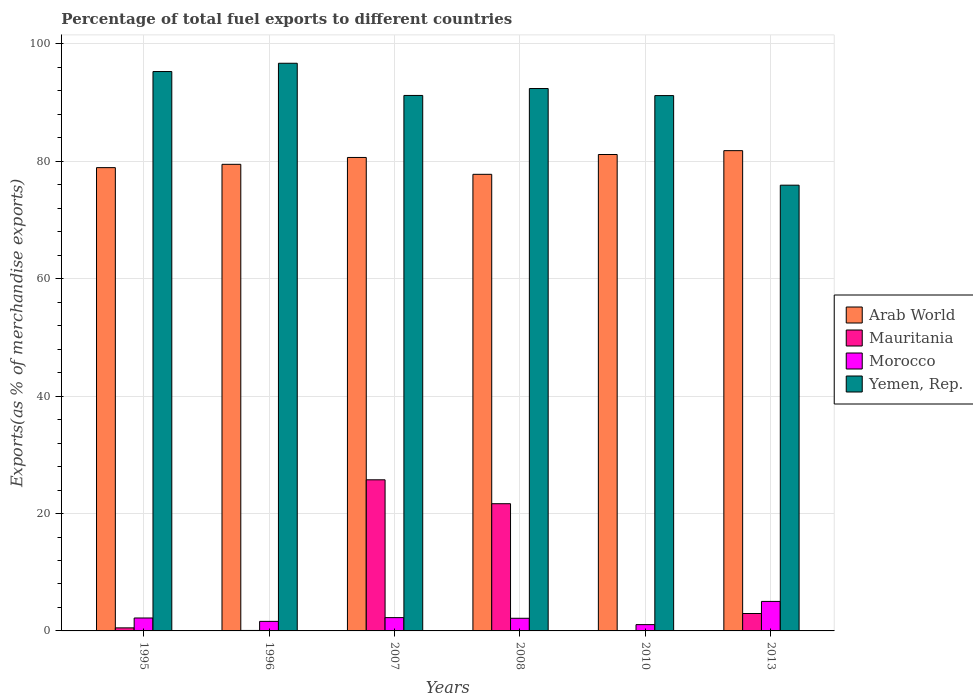How many different coloured bars are there?
Keep it short and to the point. 4. How many groups of bars are there?
Offer a very short reply. 6. Are the number of bars per tick equal to the number of legend labels?
Your answer should be compact. Yes. Are the number of bars on each tick of the X-axis equal?
Offer a terse response. Yes. How many bars are there on the 5th tick from the left?
Give a very brief answer. 4. In how many cases, is the number of bars for a given year not equal to the number of legend labels?
Your answer should be very brief. 0. What is the percentage of exports to different countries in Morocco in 2007?
Provide a succinct answer. 2.27. Across all years, what is the maximum percentage of exports to different countries in Yemen, Rep.?
Offer a very short reply. 96.71. Across all years, what is the minimum percentage of exports to different countries in Yemen, Rep.?
Provide a short and direct response. 75.94. What is the total percentage of exports to different countries in Mauritania in the graph?
Your answer should be very brief. 50.98. What is the difference between the percentage of exports to different countries in Mauritania in 2007 and that in 2013?
Your response must be concise. 22.78. What is the difference between the percentage of exports to different countries in Morocco in 2008 and the percentage of exports to different countries in Arab World in 2010?
Give a very brief answer. -79.01. What is the average percentage of exports to different countries in Mauritania per year?
Your answer should be very brief. 8.5. In the year 1995, what is the difference between the percentage of exports to different countries in Arab World and percentage of exports to different countries in Yemen, Rep.?
Provide a succinct answer. -16.37. What is the ratio of the percentage of exports to different countries in Arab World in 1995 to that in 2008?
Offer a terse response. 1.01. Is the difference between the percentage of exports to different countries in Arab World in 2007 and 2008 greater than the difference between the percentage of exports to different countries in Yemen, Rep. in 2007 and 2008?
Make the answer very short. Yes. What is the difference between the highest and the second highest percentage of exports to different countries in Mauritania?
Give a very brief answer. 4.07. What is the difference between the highest and the lowest percentage of exports to different countries in Yemen, Rep.?
Offer a terse response. 20.77. In how many years, is the percentage of exports to different countries in Mauritania greater than the average percentage of exports to different countries in Mauritania taken over all years?
Offer a very short reply. 2. What does the 1st bar from the left in 1996 represents?
Provide a succinct answer. Arab World. What does the 3rd bar from the right in 1996 represents?
Make the answer very short. Mauritania. Is it the case that in every year, the sum of the percentage of exports to different countries in Arab World and percentage of exports to different countries in Mauritania is greater than the percentage of exports to different countries in Morocco?
Keep it short and to the point. Yes. Are all the bars in the graph horizontal?
Make the answer very short. No. Are the values on the major ticks of Y-axis written in scientific E-notation?
Provide a succinct answer. No. How are the legend labels stacked?
Make the answer very short. Vertical. What is the title of the graph?
Make the answer very short. Percentage of total fuel exports to different countries. Does "Greece" appear as one of the legend labels in the graph?
Offer a very short reply. No. What is the label or title of the Y-axis?
Give a very brief answer. Exports(as % of merchandise exports). What is the Exports(as % of merchandise exports) of Arab World in 1995?
Offer a very short reply. 78.93. What is the Exports(as % of merchandise exports) in Mauritania in 1995?
Your answer should be very brief. 0.52. What is the Exports(as % of merchandise exports) of Morocco in 1995?
Make the answer very short. 2.2. What is the Exports(as % of merchandise exports) in Yemen, Rep. in 1995?
Make the answer very short. 95.3. What is the Exports(as % of merchandise exports) in Arab World in 1996?
Ensure brevity in your answer.  79.49. What is the Exports(as % of merchandise exports) of Mauritania in 1996?
Your answer should be very brief. 0.08. What is the Exports(as % of merchandise exports) in Morocco in 1996?
Your response must be concise. 1.63. What is the Exports(as % of merchandise exports) in Yemen, Rep. in 1996?
Your answer should be very brief. 96.71. What is the Exports(as % of merchandise exports) of Arab World in 2007?
Your answer should be very brief. 80.66. What is the Exports(as % of merchandise exports) in Mauritania in 2007?
Ensure brevity in your answer.  25.74. What is the Exports(as % of merchandise exports) of Morocco in 2007?
Provide a succinct answer. 2.27. What is the Exports(as % of merchandise exports) of Yemen, Rep. in 2007?
Your answer should be compact. 91.23. What is the Exports(as % of merchandise exports) of Arab World in 2008?
Provide a succinct answer. 77.79. What is the Exports(as % of merchandise exports) in Mauritania in 2008?
Provide a succinct answer. 21.67. What is the Exports(as % of merchandise exports) in Morocco in 2008?
Your response must be concise. 2.15. What is the Exports(as % of merchandise exports) of Yemen, Rep. in 2008?
Make the answer very short. 92.41. What is the Exports(as % of merchandise exports) in Arab World in 2010?
Give a very brief answer. 81.17. What is the Exports(as % of merchandise exports) of Mauritania in 2010?
Make the answer very short. 0. What is the Exports(as % of merchandise exports) of Morocco in 2010?
Your answer should be compact. 1.07. What is the Exports(as % of merchandise exports) of Yemen, Rep. in 2010?
Ensure brevity in your answer.  91.2. What is the Exports(as % of merchandise exports) in Arab World in 2013?
Your answer should be compact. 81.82. What is the Exports(as % of merchandise exports) of Mauritania in 2013?
Ensure brevity in your answer.  2.97. What is the Exports(as % of merchandise exports) in Morocco in 2013?
Provide a succinct answer. 5.03. What is the Exports(as % of merchandise exports) in Yemen, Rep. in 2013?
Give a very brief answer. 75.94. Across all years, what is the maximum Exports(as % of merchandise exports) of Arab World?
Your answer should be very brief. 81.82. Across all years, what is the maximum Exports(as % of merchandise exports) in Mauritania?
Make the answer very short. 25.74. Across all years, what is the maximum Exports(as % of merchandise exports) of Morocco?
Provide a short and direct response. 5.03. Across all years, what is the maximum Exports(as % of merchandise exports) in Yemen, Rep.?
Make the answer very short. 96.71. Across all years, what is the minimum Exports(as % of merchandise exports) in Arab World?
Your answer should be compact. 77.79. Across all years, what is the minimum Exports(as % of merchandise exports) in Mauritania?
Your answer should be compact. 0. Across all years, what is the minimum Exports(as % of merchandise exports) in Morocco?
Your answer should be compact. 1.07. Across all years, what is the minimum Exports(as % of merchandise exports) in Yemen, Rep.?
Your response must be concise. 75.94. What is the total Exports(as % of merchandise exports) in Arab World in the graph?
Keep it short and to the point. 479.87. What is the total Exports(as % of merchandise exports) of Mauritania in the graph?
Your answer should be compact. 50.98. What is the total Exports(as % of merchandise exports) of Morocco in the graph?
Make the answer very short. 14.35. What is the total Exports(as % of merchandise exports) in Yemen, Rep. in the graph?
Offer a very short reply. 542.79. What is the difference between the Exports(as % of merchandise exports) in Arab World in 1995 and that in 1996?
Provide a succinct answer. -0.56. What is the difference between the Exports(as % of merchandise exports) of Mauritania in 1995 and that in 1996?
Make the answer very short. 0.44. What is the difference between the Exports(as % of merchandise exports) of Morocco in 1995 and that in 1996?
Ensure brevity in your answer.  0.58. What is the difference between the Exports(as % of merchandise exports) of Yemen, Rep. in 1995 and that in 1996?
Keep it short and to the point. -1.41. What is the difference between the Exports(as % of merchandise exports) of Arab World in 1995 and that in 2007?
Keep it short and to the point. -1.73. What is the difference between the Exports(as % of merchandise exports) in Mauritania in 1995 and that in 2007?
Provide a succinct answer. -25.23. What is the difference between the Exports(as % of merchandise exports) in Morocco in 1995 and that in 2007?
Your answer should be compact. -0.07. What is the difference between the Exports(as % of merchandise exports) of Yemen, Rep. in 1995 and that in 2007?
Provide a succinct answer. 4.07. What is the difference between the Exports(as % of merchandise exports) in Arab World in 1995 and that in 2008?
Offer a very short reply. 1.14. What is the difference between the Exports(as % of merchandise exports) of Mauritania in 1995 and that in 2008?
Your response must be concise. -21.15. What is the difference between the Exports(as % of merchandise exports) in Morocco in 1995 and that in 2008?
Your response must be concise. 0.05. What is the difference between the Exports(as % of merchandise exports) of Yemen, Rep. in 1995 and that in 2008?
Make the answer very short. 2.89. What is the difference between the Exports(as % of merchandise exports) of Arab World in 1995 and that in 2010?
Keep it short and to the point. -2.24. What is the difference between the Exports(as % of merchandise exports) of Mauritania in 1995 and that in 2010?
Your answer should be very brief. 0.52. What is the difference between the Exports(as % of merchandise exports) in Morocco in 1995 and that in 2010?
Your answer should be compact. 1.13. What is the difference between the Exports(as % of merchandise exports) of Yemen, Rep. in 1995 and that in 2010?
Your answer should be compact. 4.1. What is the difference between the Exports(as % of merchandise exports) of Arab World in 1995 and that in 2013?
Ensure brevity in your answer.  -2.89. What is the difference between the Exports(as % of merchandise exports) of Mauritania in 1995 and that in 2013?
Offer a very short reply. -2.45. What is the difference between the Exports(as % of merchandise exports) in Morocco in 1995 and that in 2013?
Offer a terse response. -2.83. What is the difference between the Exports(as % of merchandise exports) in Yemen, Rep. in 1995 and that in 2013?
Keep it short and to the point. 19.36. What is the difference between the Exports(as % of merchandise exports) of Arab World in 1996 and that in 2007?
Keep it short and to the point. -1.17. What is the difference between the Exports(as % of merchandise exports) of Mauritania in 1996 and that in 2007?
Give a very brief answer. -25.66. What is the difference between the Exports(as % of merchandise exports) in Morocco in 1996 and that in 2007?
Make the answer very short. -0.64. What is the difference between the Exports(as % of merchandise exports) in Yemen, Rep. in 1996 and that in 2007?
Ensure brevity in your answer.  5.48. What is the difference between the Exports(as % of merchandise exports) of Arab World in 1996 and that in 2008?
Your answer should be very brief. 1.7. What is the difference between the Exports(as % of merchandise exports) of Mauritania in 1996 and that in 2008?
Offer a terse response. -21.59. What is the difference between the Exports(as % of merchandise exports) in Morocco in 1996 and that in 2008?
Your answer should be compact. -0.53. What is the difference between the Exports(as % of merchandise exports) in Yemen, Rep. in 1996 and that in 2008?
Offer a terse response. 4.3. What is the difference between the Exports(as % of merchandise exports) of Arab World in 1996 and that in 2010?
Make the answer very short. -1.67. What is the difference between the Exports(as % of merchandise exports) in Mauritania in 1996 and that in 2010?
Offer a terse response. 0.08. What is the difference between the Exports(as % of merchandise exports) in Morocco in 1996 and that in 2010?
Provide a succinct answer. 0.55. What is the difference between the Exports(as % of merchandise exports) of Yemen, Rep. in 1996 and that in 2010?
Provide a short and direct response. 5.51. What is the difference between the Exports(as % of merchandise exports) of Arab World in 1996 and that in 2013?
Provide a short and direct response. -2.33. What is the difference between the Exports(as % of merchandise exports) of Mauritania in 1996 and that in 2013?
Your response must be concise. -2.89. What is the difference between the Exports(as % of merchandise exports) of Morocco in 1996 and that in 2013?
Offer a terse response. -3.4. What is the difference between the Exports(as % of merchandise exports) of Yemen, Rep. in 1996 and that in 2013?
Offer a very short reply. 20.77. What is the difference between the Exports(as % of merchandise exports) of Arab World in 2007 and that in 2008?
Ensure brevity in your answer.  2.87. What is the difference between the Exports(as % of merchandise exports) in Mauritania in 2007 and that in 2008?
Give a very brief answer. 4.07. What is the difference between the Exports(as % of merchandise exports) in Morocco in 2007 and that in 2008?
Make the answer very short. 0.11. What is the difference between the Exports(as % of merchandise exports) of Yemen, Rep. in 2007 and that in 2008?
Your response must be concise. -1.18. What is the difference between the Exports(as % of merchandise exports) in Arab World in 2007 and that in 2010?
Ensure brevity in your answer.  -0.5. What is the difference between the Exports(as % of merchandise exports) in Mauritania in 2007 and that in 2010?
Your answer should be very brief. 25.74. What is the difference between the Exports(as % of merchandise exports) in Morocco in 2007 and that in 2010?
Offer a terse response. 1.19. What is the difference between the Exports(as % of merchandise exports) in Yemen, Rep. in 2007 and that in 2010?
Provide a short and direct response. 0.02. What is the difference between the Exports(as % of merchandise exports) in Arab World in 2007 and that in 2013?
Offer a very short reply. -1.16. What is the difference between the Exports(as % of merchandise exports) in Mauritania in 2007 and that in 2013?
Your response must be concise. 22.78. What is the difference between the Exports(as % of merchandise exports) in Morocco in 2007 and that in 2013?
Make the answer very short. -2.76. What is the difference between the Exports(as % of merchandise exports) of Yemen, Rep. in 2007 and that in 2013?
Your response must be concise. 15.29. What is the difference between the Exports(as % of merchandise exports) of Arab World in 2008 and that in 2010?
Give a very brief answer. -3.37. What is the difference between the Exports(as % of merchandise exports) of Mauritania in 2008 and that in 2010?
Your response must be concise. 21.67. What is the difference between the Exports(as % of merchandise exports) in Morocco in 2008 and that in 2010?
Make the answer very short. 1.08. What is the difference between the Exports(as % of merchandise exports) of Yemen, Rep. in 2008 and that in 2010?
Offer a terse response. 1.2. What is the difference between the Exports(as % of merchandise exports) of Arab World in 2008 and that in 2013?
Offer a very short reply. -4.03. What is the difference between the Exports(as % of merchandise exports) of Mauritania in 2008 and that in 2013?
Provide a succinct answer. 18.7. What is the difference between the Exports(as % of merchandise exports) in Morocco in 2008 and that in 2013?
Your response must be concise. -2.87. What is the difference between the Exports(as % of merchandise exports) of Yemen, Rep. in 2008 and that in 2013?
Your response must be concise. 16.47. What is the difference between the Exports(as % of merchandise exports) in Arab World in 2010 and that in 2013?
Offer a terse response. -0.66. What is the difference between the Exports(as % of merchandise exports) in Mauritania in 2010 and that in 2013?
Ensure brevity in your answer.  -2.97. What is the difference between the Exports(as % of merchandise exports) of Morocco in 2010 and that in 2013?
Your answer should be very brief. -3.96. What is the difference between the Exports(as % of merchandise exports) in Yemen, Rep. in 2010 and that in 2013?
Your answer should be very brief. 15.27. What is the difference between the Exports(as % of merchandise exports) of Arab World in 1995 and the Exports(as % of merchandise exports) of Mauritania in 1996?
Keep it short and to the point. 78.85. What is the difference between the Exports(as % of merchandise exports) in Arab World in 1995 and the Exports(as % of merchandise exports) in Morocco in 1996?
Your answer should be very brief. 77.3. What is the difference between the Exports(as % of merchandise exports) in Arab World in 1995 and the Exports(as % of merchandise exports) in Yemen, Rep. in 1996?
Offer a very short reply. -17.78. What is the difference between the Exports(as % of merchandise exports) of Mauritania in 1995 and the Exports(as % of merchandise exports) of Morocco in 1996?
Make the answer very short. -1.11. What is the difference between the Exports(as % of merchandise exports) in Mauritania in 1995 and the Exports(as % of merchandise exports) in Yemen, Rep. in 1996?
Ensure brevity in your answer.  -96.19. What is the difference between the Exports(as % of merchandise exports) of Morocco in 1995 and the Exports(as % of merchandise exports) of Yemen, Rep. in 1996?
Keep it short and to the point. -94.51. What is the difference between the Exports(as % of merchandise exports) in Arab World in 1995 and the Exports(as % of merchandise exports) in Mauritania in 2007?
Ensure brevity in your answer.  53.19. What is the difference between the Exports(as % of merchandise exports) of Arab World in 1995 and the Exports(as % of merchandise exports) of Morocco in 2007?
Your answer should be very brief. 76.66. What is the difference between the Exports(as % of merchandise exports) in Arab World in 1995 and the Exports(as % of merchandise exports) in Yemen, Rep. in 2007?
Offer a terse response. -12.3. What is the difference between the Exports(as % of merchandise exports) of Mauritania in 1995 and the Exports(as % of merchandise exports) of Morocco in 2007?
Your response must be concise. -1.75. What is the difference between the Exports(as % of merchandise exports) of Mauritania in 1995 and the Exports(as % of merchandise exports) of Yemen, Rep. in 2007?
Your answer should be compact. -90.71. What is the difference between the Exports(as % of merchandise exports) of Morocco in 1995 and the Exports(as % of merchandise exports) of Yemen, Rep. in 2007?
Offer a very short reply. -89.02. What is the difference between the Exports(as % of merchandise exports) of Arab World in 1995 and the Exports(as % of merchandise exports) of Mauritania in 2008?
Your answer should be very brief. 57.26. What is the difference between the Exports(as % of merchandise exports) in Arab World in 1995 and the Exports(as % of merchandise exports) in Morocco in 2008?
Make the answer very short. 76.78. What is the difference between the Exports(as % of merchandise exports) in Arab World in 1995 and the Exports(as % of merchandise exports) in Yemen, Rep. in 2008?
Make the answer very short. -13.48. What is the difference between the Exports(as % of merchandise exports) of Mauritania in 1995 and the Exports(as % of merchandise exports) of Morocco in 2008?
Offer a terse response. -1.63. What is the difference between the Exports(as % of merchandise exports) in Mauritania in 1995 and the Exports(as % of merchandise exports) in Yemen, Rep. in 2008?
Give a very brief answer. -91.89. What is the difference between the Exports(as % of merchandise exports) in Morocco in 1995 and the Exports(as % of merchandise exports) in Yemen, Rep. in 2008?
Give a very brief answer. -90.2. What is the difference between the Exports(as % of merchandise exports) in Arab World in 1995 and the Exports(as % of merchandise exports) in Mauritania in 2010?
Give a very brief answer. 78.93. What is the difference between the Exports(as % of merchandise exports) in Arab World in 1995 and the Exports(as % of merchandise exports) in Morocco in 2010?
Your answer should be very brief. 77.86. What is the difference between the Exports(as % of merchandise exports) in Arab World in 1995 and the Exports(as % of merchandise exports) in Yemen, Rep. in 2010?
Offer a very short reply. -12.27. What is the difference between the Exports(as % of merchandise exports) of Mauritania in 1995 and the Exports(as % of merchandise exports) of Morocco in 2010?
Your answer should be compact. -0.55. What is the difference between the Exports(as % of merchandise exports) of Mauritania in 1995 and the Exports(as % of merchandise exports) of Yemen, Rep. in 2010?
Your answer should be very brief. -90.69. What is the difference between the Exports(as % of merchandise exports) of Morocco in 1995 and the Exports(as % of merchandise exports) of Yemen, Rep. in 2010?
Give a very brief answer. -89. What is the difference between the Exports(as % of merchandise exports) in Arab World in 1995 and the Exports(as % of merchandise exports) in Mauritania in 2013?
Your answer should be very brief. 75.96. What is the difference between the Exports(as % of merchandise exports) in Arab World in 1995 and the Exports(as % of merchandise exports) in Morocco in 2013?
Your answer should be very brief. 73.9. What is the difference between the Exports(as % of merchandise exports) of Arab World in 1995 and the Exports(as % of merchandise exports) of Yemen, Rep. in 2013?
Ensure brevity in your answer.  2.99. What is the difference between the Exports(as % of merchandise exports) in Mauritania in 1995 and the Exports(as % of merchandise exports) in Morocco in 2013?
Offer a very short reply. -4.51. What is the difference between the Exports(as % of merchandise exports) of Mauritania in 1995 and the Exports(as % of merchandise exports) of Yemen, Rep. in 2013?
Offer a terse response. -75.42. What is the difference between the Exports(as % of merchandise exports) in Morocco in 1995 and the Exports(as % of merchandise exports) in Yemen, Rep. in 2013?
Ensure brevity in your answer.  -73.74. What is the difference between the Exports(as % of merchandise exports) in Arab World in 1996 and the Exports(as % of merchandise exports) in Mauritania in 2007?
Your response must be concise. 53.75. What is the difference between the Exports(as % of merchandise exports) in Arab World in 1996 and the Exports(as % of merchandise exports) in Morocco in 2007?
Offer a very short reply. 77.23. What is the difference between the Exports(as % of merchandise exports) in Arab World in 1996 and the Exports(as % of merchandise exports) in Yemen, Rep. in 2007?
Offer a terse response. -11.73. What is the difference between the Exports(as % of merchandise exports) of Mauritania in 1996 and the Exports(as % of merchandise exports) of Morocco in 2007?
Give a very brief answer. -2.19. What is the difference between the Exports(as % of merchandise exports) of Mauritania in 1996 and the Exports(as % of merchandise exports) of Yemen, Rep. in 2007?
Make the answer very short. -91.15. What is the difference between the Exports(as % of merchandise exports) of Morocco in 1996 and the Exports(as % of merchandise exports) of Yemen, Rep. in 2007?
Make the answer very short. -89.6. What is the difference between the Exports(as % of merchandise exports) of Arab World in 1996 and the Exports(as % of merchandise exports) of Mauritania in 2008?
Give a very brief answer. 57.82. What is the difference between the Exports(as % of merchandise exports) in Arab World in 1996 and the Exports(as % of merchandise exports) in Morocco in 2008?
Make the answer very short. 77.34. What is the difference between the Exports(as % of merchandise exports) of Arab World in 1996 and the Exports(as % of merchandise exports) of Yemen, Rep. in 2008?
Provide a succinct answer. -12.91. What is the difference between the Exports(as % of merchandise exports) in Mauritania in 1996 and the Exports(as % of merchandise exports) in Morocco in 2008?
Make the answer very short. -2.07. What is the difference between the Exports(as % of merchandise exports) of Mauritania in 1996 and the Exports(as % of merchandise exports) of Yemen, Rep. in 2008?
Make the answer very short. -92.33. What is the difference between the Exports(as % of merchandise exports) in Morocco in 1996 and the Exports(as % of merchandise exports) in Yemen, Rep. in 2008?
Offer a terse response. -90.78. What is the difference between the Exports(as % of merchandise exports) in Arab World in 1996 and the Exports(as % of merchandise exports) in Mauritania in 2010?
Give a very brief answer. 79.49. What is the difference between the Exports(as % of merchandise exports) in Arab World in 1996 and the Exports(as % of merchandise exports) in Morocco in 2010?
Offer a very short reply. 78.42. What is the difference between the Exports(as % of merchandise exports) of Arab World in 1996 and the Exports(as % of merchandise exports) of Yemen, Rep. in 2010?
Ensure brevity in your answer.  -11.71. What is the difference between the Exports(as % of merchandise exports) of Mauritania in 1996 and the Exports(as % of merchandise exports) of Morocco in 2010?
Offer a very short reply. -0.99. What is the difference between the Exports(as % of merchandise exports) in Mauritania in 1996 and the Exports(as % of merchandise exports) in Yemen, Rep. in 2010?
Ensure brevity in your answer.  -91.13. What is the difference between the Exports(as % of merchandise exports) of Morocco in 1996 and the Exports(as % of merchandise exports) of Yemen, Rep. in 2010?
Make the answer very short. -89.58. What is the difference between the Exports(as % of merchandise exports) in Arab World in 1996 and the Exports(as % of merchandise exports) in Mauritania in 2013?
Give a very brief answer. 76.53. What is the difference between the Exports(as % of merchandise exports) of Arab World in 1996 and the Exports(as % of merchandise exports) of Morocco in 2013?
Make the answer very short. 74.47. What is the difference between the Exports(as % of merchandise exports) in Arab World in 1996 and the Exports(as % of merchandise exports) in Yemen, Rep. in 2013?
Your answer should be compact. 3.56. What is the difference between the Exports(as % of merchandise exports) of Mauritania in 1996 and the Exports(as % of merchandise exports) of Morocco in 2013?
Your response must be concise. -4.95. What is the difference between the Exports(as % of merchandise exports) in Mauritania in 1996 and the Exports(as % of merchandise exports) in Yemen, Rep. in 2013?
Ensure brevity in your answer.  -75.86. What is the difference between the Exports(as % of merchandise exports) in Morocco in 1996 and the Exports(as % of merchandise exports) in Yemen, Rep. in 2013?
Offer a terse response. -74.31. What is the difference between the Exports(as % of merchandise exports) of Arab World in 2007 and the Exports(as % of merchandise exports) of Mauritania in 2008?
Give a very brief answer. 58.99. What is the difference between the Exports(as % of merchandise exports) in Arab World in 2007 and the Exports(as % of merchandise exports) in Morocco in 2008?
Offer a very short reply. 78.51. What is the difference between the Exports(as % of merchandise exports) in Arab World in 2007 and the Exports(as % of merchandise exports) in Yemen, Rep. in 2008?
Ensure brevity in your answer.  -11.74. What is the difference between the Exports(as % of merchandise exports) in Mauritania in 2007 and the Exports(as % of merchandise exports) in Morocco in 2008?
Your response must be concise. 23.59. What is the difference between the Exports(as % of merchandise exports) of Mauritania in 2007 and the Exports(as % of merchandise exports) of Yemen, Rep. in 2008?
Offer a very short reply. -66.66. What is the difference between the Exports(as % of merchandise exports) in Morocco in 2007 and the Exports(as % of merchandise exports) in Yemen, Rep. in 2008?
Your response must be concise. -90.14. What is the difference between the Exports(as % of merchandise exports) in Arab World in 2007 and the Exports(as % of merchandise exports) in Mauritania in 2010?
Provide a short and direct response. 80.66. What is the difference between the Exports(as % of merchandise exports) in Arab World in 2007 and the Exports(as % of merchandise exports) in Morocco in 2010?
Your response must be concise. 79.59. What is the difference between the Exports(as % of merchandise exports) in Arab World in 2007 and the Exports(as % of merchandise exports) in Yemen, Rep. in 2010?
Your answer should be very brief. -10.54. What is the difference between the Exports(as % of merchandise exports) in Mauritania in 2007 and the Exports(as % of merchandise exports) in Morocco in 2010?
Keep it short and to the point. 24.67. What is the difference between the Exports(as % of merchandise exports) of Mauritania in 2007 and the Exports(as % of merchandise exports) of Yemen, Rep. in 2010?
Provide a short and direct response. -65.46. What is the difference between the Exports(as % of merchandise exports) of Morocco in 2007 and the Exports(as % of merchandise exports) of Yemen, Rep. in 2010?
Keep it short and to the point. -88.94. What is the difference between the Exports(as % of merchandise exports) in Arab World in 2007 and the Exports(as % of merchandise exports) in Mauritania in 2013?
Ensure brevity in your answer.  77.7. What is the difference between the Exports(as % of merchandise exports) in Arab World in 2007 and the Exports(as % of merchandise exports) in Morocco in 2013?
Offer a very short reply. 75.64. What is the difference between the Exports(as % of merchandise exports) of Arab World in 2007 and the Exports(as % of merchandise exports) of Yemen, Rep. in 2013?
Your answer should be compact. 4.72. What is the difference between the Exports(as % of merchandise exports) in Mauritania in 2007 and the Exports(as % of merchandise exports) in Morocco in 2013?
Offer a terse response. 20.72. What is the difference between the Exports(as % of merchandise exports) in Mauritania in 2007 and the Exports(as % of merchandise exports) in Yemen, Rep. in 2013?
Keep it short and to the point. -50.19. What is the difference between the Exports(as % of merchandise exports) in Morocco in 2007 and the Exports(as % of merchandise exports) in Yemen, Rep. in 2013?
Your answer should be compact. -73.67. What is the difference between the Exports(as % of merchandise exports) in Arab World in 2008 and the Exports(as % of merchandise exports) in Mauritania in 2010?
Ensure brevity in your answer.  77.79. What is the difference between the Exports(as % of merchandise exports) of Arab World in 2008 and the Exports(as % of merchandise exports) of Morocco in 2010?
Provide a succinct answer. 76.72. What is the difference between the Exports(as % of merchandise exports) of Arab World in 2008 and the Exports(as % of merchandise exports) of Yemen, Rep. in 2010?
Make the answer very short. -13.41. What is the difference between the Exports(as % of merchandise exports) in Mauritania in 2008 and the Exports(as % of merchandise exports) in Morocco in 2010?
Give a very brief answer. 20.6. What is the difference between the Exports(as % of merchandise exports) in Mauritania in 2008 and the Exports(as % of merchandise exports) in Yemen, Rep. in 2010?
Offer a terse response. -69.53. What is the difference between the Exports(as % of merchandise exports) in Morocco in 2008 and the Exports(as % of merchandise exports) in Yemen, Rep. in 2010?
Your answer should be compact. -89.05. What is the difference between the Exports(as % of merchandise exports) in Arab World in 2008 and the Exports(as % of merchandise exports) in Mauritania in 2013?
Provide a short and direct response. 74.82. What is the difference between the Exports(as % of merchandise exports) of Arab World in 2008 and the Exports(as % of merchandise exports) of Morocco in 2013?
Provide a short and direct response. 72.76. What is the difference between the Exports(as % of merchandise exports) of Arab World in 2008 and the Exports(as % of merchandise exports) of Yemen, Rep. in 2013?
Offer a terse response. 1.85. What is the difference between the Exports(as % of merchandise exports) in Mauritania in 2008 and the Exports(as % of merchandise exports) in Morocco in 2013?
Your answer should be very brief. 16.64. What is the difference between the Exports(as % of merchandise exports) in Mauritania in 2008 and the Exports(as % of merchandise exports) in Yemen, Rep. in 2013?
Your answer should be compact. -54.27. What is the difference between the Exports(as % of merchandise exports) in Morocco in 2008 and the Exports(as % of merchandise exports) in Yemen, Rep. in 2013?
Keep it short and to the point. -73.78. What is the difference between the Exports(as % of merchandise exports) of Arab World in 2010 and the Exports(as % of merchandise exports) of Mauritania in 2013?
Provide a short and direct response. 78.2. What is the difference between the Exports(as % of merchandise exports) in Arab World in 2010 and the Exports(as % of merchandise exports) in Morocco in 2013?
Your answer should be compact. 76.14. What is the difference between the Exports(as % of merchandise exports) of Arab World in 2010 and the Exports(as % of merchandise exports) of Yemen, Rep. in 2013?
Your answer should be compact. 5.23. What is the difference between the Exports(as % of merchandise exports) in Mauritania in 2010 and the Exports(as % of merchandise exports) in Morocco in 2013?
Provide a short and direct response. -5.03. What is the difference between the Exports(as % of merchandise exports) in Mauritania in 2010 and the Exports(as % of merchandise exports) in Yemen, Rep. in 2013?
Your response must be concise. -75.94. What is the difference between the Exports(as % of merchandise exports) of Morocco in 2010 and the Exports(as % of merchandise exports) of Yemen, Rep. in 2013?
Your answer should be compact. -74.87. What is the average Exports(as % of merchandise exports) in Arab World per year?
Give a very brief answer. 79.98. What is the average Exports(as % of merchandise exports) of Mauritania per year?
Ensure brevity in your answer.  8.5. What is the average Exports(as % of merchandise exports) of Morocco per year?
Provide a succinct answer. 2.39. What is the average Exports(as % of merchandise exports) of Yemen, Rep. per year?
Offer a very short reply. 90.47. In the year 1995, what is the difference between the Exports(as % of merchandise exports) in Arab World and Exports(as % of merchandise exports) in Mauritania?
Provide a short and direct response. 78.41. In the year 1995, what is the difference between the Exports(as % of merchandise exports) in Arab World and Exports(as % of merchandise exports) in Morocco?
Make the answer very short. 76.73. In the year 1995, what is the difference between the Exports(as % of merchandise exports) in Arab World and Exports(as % of merchandise exports) in Yemen, Rep.?
Provide a succinct answer. -16.37. In the year 1995, what is the difference between the Exports(as % of merchandise exports) of Mauritania and Exports(as % of merchandise exports) of Morocco?
Provide a short and direct response. -1.68. In the year 1995, what is the difference between the Exports(as % of merchandise exports) of Mauritania and Exports(as % of merchandise exports) of Yemen, Rep.?
Offer a terse response. -94.78. In the year 1995, what is the difference between the Exports(as % of merchandise exports) in Morocco and Exports(as % of merchandise exports) in Yemen, Rep.?
Offer a terse response. -93.1. In the year 1996, what is the difference between the Exports(as % of merchandise exports) of Arab World and Exports(as % of merchandise exports) of Mauritania?
Ensure brevity in your answer.  79.42. In the year 1996, what is the difference between the Exports(as % of merchandise exports) in Arab World and Exports(as % of merchandise exports) in Morocco?
Offer a very short reply. 77.87. In the year 1996, what is the difference between the Exports(as % of merchandise exports) in Arab World and Exports(as % of merchandise exports) in Yemen, Rep.?
Your answer should be very brief. -17.22. In the year 1996, what is the difference between the Exports(as % of merchandise exports) in Mauritania and Exports(as % of merchandise exports) in Morocco?
Provide a succinct answer. -1.55. In the year 1996, what is the difference between the Exports(as % of merchandise exports) in Mauritania and Exports(as % of merchandise exports) in Yemen, Rep.?
Provide a short and direct response. -96.63. In the year 1996, what is the difference between the Exports(as % of merchandise exports) in Morocco and Exports(as % of merchandise exports) in Yemen, Rep.?
Offer a very short reply. -95.08. In the year 2007, what is the difference between the Exports(as % of merchandise exports) of Arab World and Exports(as % of merchandise exports) of Mauritania?
Your answer should be very brief. 54.92. In the year 2007, what is the difference between the Exports(as % of merchandise exports) of Arab World and Exports(as % of merchandise exports) of Morocco?
Your answer should be very brief. 78.4. In the year 2007, what is the difference between the Exports(as % of merchandise exports) of Arab World and Exports(as % of merchandise exports) of Yemen, Rep.?
Provide a short and direct response. -10.56. In the year 2007, what is the difference between the Exports(as % of merchandise exports) in Mauritania and Exports(as % of merchandise exports) in Morocco?
Your response must be concise. 23.48. In the year 2007, what is the difference between the Exports(as % of merchandise exports) in Mauritania and Exports(as % of merchandise exports) in Yemen, Rep.?
Give a very brief answer. -65.48. In the year 2007, what is the difference between the Exports(as % of merchandise exports) in Morocco and Exports(as % of merchandise exports) in Yemen, Rep.?
Keep it short and to the point. -88.96. In the year 2008, what is the difference between the Exports(as % of merchandise exports) in Arab World and Exports(as % of merchandise exports) in Mauritania?
Your answer should be compact. 56.12. In the year 2008, what is the difference between the Exports(as % of merchandise exports) in Arab World and Exports(as % of merchandise exports) in Morocco?
Offer a very short reply. 75.64. In the year 2008, what is the difference between the Exports(as % of merchandise exports) in Arab World and Exports(as % of merchandise exports) in Yemen, Rep.?
Offer a terse response. -14.62. In the year 2008, what is the difference between the Exports(as % of merchandise exports) in Mauritania and Exports(as % of merchandise exports) in Morocco?
Provide a short and direct response. 19.52. In the year 2008, what is the difference between the Exports(as % of merchandise exports) in Mauritania and Exports(as % of merchandise exports) in Yemen, Rep.?
Your response must be concise. -70.74. In the year 2008, what is the difference between the Exports(as % of merchandise exports) in Morocco and Exports(as % of merchandise exports) in Yemen, Rep.?
Your response must be concise. -90.25. In the year 2010, what is the difference between the Exports(as % of merchandise exports) of Arab World and Exports(as % of merchandise exports) of Mauritania?
Provide a succinct answer. 81.16. In the year 2010, what is the difference between the Exports(as % of merchandise exports) of Arab World and Exports(as % of merchandise exports) of Morocco?
Make the answer very short. 80.09. In the year 2010, what is the difference between the Exports(as % of merchandise exports) in Arab World and Exports(as % of merchandise exports) in Yemen, Rep.?
Provide a succinct answer. -10.04. In the year 2010, what is the difference between the Exports(as % of merchandise exports) of Mauritania and Exports(as % of merchandise exports) of Morocco?
Offer a terse response. -1.07. In the year 2010, what is the difference between the Exports(as % of merchandise exports) in Mauritania and Exports(as % of merchandise exports) in Yemen, Rep.?
Keep it short and to the point. -91.2. In the year 2010, what is the difference between the Exports(as % of merchandise exports) of Morocco and Exports(as % of merchandise exports) of Yemen, Rep.?
Make the answer very short. -90.13. In the year 2013, what is the difference between the Exports(as % of merchandise exports) of Arab World and Exports(as % of merchandise exports) of Mauritania?
Ensure brevity in your answer.  78.86. In the year 2013, what is the difference between the Exports(as % of merchandise exports) of Arab World and Exports(as % of merchandise exports) of Morocco?
Provide a succinct answer. 76.8. In the year 2013, what is the difference between the Exports(as % of merchandise exports) of Arab World and Exports(as % of merchandise exports) of Yemen, Rep.?
Make the answer very short. 5.88. In the year 2013, what is the difference between the Exports(as % of merchandise exports) in Mauritania and Exports(as % of merchandise exports) in Morocco?
Offer a terse response. -2.06. In the year 2013, what is the difference between the Exports(as % of merchandise exports) of Mauritania and Exports(as % of merchandise exports) of Yemen, Rep.?
Your answer should be compact. -72.97. In the year 2013, what is the difference between the Exports(as % of merchandise exports) in Morocco and Exports(as % of merchandise exports) in Yemen, Rep.?
Your response must be concise. -70.91. What is the ratio of the Exports(as % of merchandise exports) of Arab World in 1995 to that in 1996?
Make the answer very short. 0.99. What is the ratio of the Exports(as % of merchandise exports) of Mauritania in 1995 to that in 1996?
Ensure brevity in your answer.  6.51. What is the ratio of the Exports(as % of merchandise exports) in Morocco in 1995 to that in 1996?
Offer a terse response. 1.35. What is the ratio of the Exports(as % of merchandise exports) of Yemen, Rep. in 1995 to that in 1996?
Keep it short and to the point. 0.99. What is the ratio of the Exports(as % of merchandise exports) of Arab World in 1995 to that in 2007?
Offer a terse response. 0.98. What is the ratio of the Exports(as % of merchandise exports) of Mauritania in 1995 to that in 2007?
Ensure brevity in your answer.  0.02. What is the ratio of the Exports(as % of merchandise exports) in Morocco in 1995 to that in 2007?
Keep it short and to the point. 0.97. What is the ratio of the Exports(as % of merchandise exports) in Yemen, Rep. in 1995 to that in 2007?
Your answer should be compact. 1.04. What is the ratio of the Exports(as % of merchandise exports) in Arab World in 1995 to that in 2008?
Provide a short and direct response. 1.01. What is the ratio of the Exports(as % of merchandise exports) in Mauritania in 1995 to that in 2008?
Offer a terse response. 0.02. What is the ratio of the Exports(as % of merchandise exports) of Morocco in 1995 to that in 2008?
Your answer should be very brief. 1.02. What is the ratio of the Exports(as % of merchandise exports) of Yemen, Rep. in 1995 to that in 2008?
Provide a short and direct response. 1.03. What is the ratio of the Exports(as % of merchandise exports) of Arab World in 1995 to that in 2010?
Provide a succinct answer. 0.97. What is the ratio of the Exports(as % of merchandise exports) of Mauritania in 1995 to that in 2010?
Provide a succinct answer. 313.82. What is the ratio of the Exports(as % of merchandise exports) in Morocco in 1995 to that in 2010?
Provide a succinct answer. 2.05. What is the ratio of the Exports(as % of merchandise exports) in Yemen, Rep. in 1995 to that in 2010?
Your answer should be very brief. 1.04. What is the ratio of the Exports(as % of merchandise exports) in Arab World in 1995 to that in 2013?
Your answer should be compact. 0.96. What is the ratio of the Exports(as % of merchandise exports) in Mauritania in 1995 to that in 2013?
Your answer should be very brief. 0.17. What is the ratio of the Exports(as % of merchandise exports) in Morocco in 1995 to that in 2013?
Make the answer very short. 0.44. What is the ratio of the Exports(as % of merchandise exports) in Yemen, Rep. in 1995 to that in 2013?
Your response must be concise. 1.25. What is the ratio of the Exports(as % of merchandise exports) in Arab World in 1996 to that in 2007?
Make the answer very short. 0.99. What is the ratio of the Exports(as % of merchandise exports) of Mauritania in 1996 to that in 2007?
Keep it short and to the point. 0. What is the ratio of the Exports(as % of merchandise exports) in Morocco in 1996 to that in 2007?
Ensure brevity in your answer.  0.72. What is the ratio of the Exports(as % of merchandise exports) in Yemen, Rep. in 1996 to that in 2007?
Offer a very short reply. 1.06. What is the ratio of the Exports(as % of merchandise exports) in Arab World in 1996 to that in 2008?
Offer a very short reply. 1.02. What is the ratio of the Exports(as % of merchandise exports) in Mauritania in 1996 to that in 2008?
Offer a very short reply. 0. What is the ratio of the Exports(as % of merchandise exports) of Morocco in 1996 to that in 2008?
Offer a very short reply. 0.76. What is the ratio of the Exports(as % of merchandise exports) in Yemen, Rep. in 1996 to that in 2008?
Provide a short and direct response. 1.05. What is the ratio of the Exports(as % of merchandise exports) in Arab World in 1996 to that in 2010?
Your answer should be compact. 0.98. What is the ratio of the Exports(as % of merchandise exports) of Mauritania in 1996 to that in 2010?
Offer a terse response. 48.21. What is the ratio of the Exports(as % of merchandise exports) of Morocco in 1996 to that in 2010?
Your answer should be very brief. 1.52. What is the ratio of the Exports(as % of merchandise exports) in Yemen, Rep. in 1996 to that in 2010?
Ensure brevity in your answer.  1.06. What is the ratio of the Exports(as % of merchandise exports) of Arab World in 1996 to that in 2013?
Your response must be concise. 0.97. What is the ratio of the Exports(as % of merchandise exports) of Mauritania in 1996 to that in 2013?
Make the answer very short. 0.03. What is the ratio of the Exports(as % of merchandise exports) of Morocco in 1996 to that in 2013?
Your answer should be compact. 0.32. What is the ratio of the Exports(as % of merchandise exports) of Yemen, Rep. in 1996 to that in 2013?
Your answer should be compact. 1.27. What is the ratio of the Exports(as % of merchandise exports) of Arab World in 2007 to that in 2008?
Your answer should be compact. 1.04. What is the ratio of the Exports(as % of merchandise exports) of Mauritania in 2007 to that in 2008?
Offer a terse response. 1.19. What is the ratio of the Exports(as % of merchandise exports) of Morocco in 2007 to that in 2008?
Give a very brief answer. 1.05. What is the ratio of the Exports(as % of merchandise exports) of Yemen, Rep. in 2007 to that in 2008?
Your answer should be compact. 0.99. What is the ratio of the Exports(as % of merchandise exports) of Mauritania in 2007 to that in 2010?
Ensure brevity in your answer.  1.56e+04. What is the ratio of the Exports(as % of merchandise exports) in Morocco in 2007 to that in 2010?
Provide a short and direct response. 2.11. What is the ratio of the Exports(as % of merchandise exports) of Arab World in 2007 to that in 2013?
Provide a short and direct response. 0.99. What is the ratio of the Exports(as % of merchandise exports) of Mauritania in 2007 to that in 2013?
Ensure brevity in your answer.  8.67. What is the ratio of the Exports(as % of merchandise exports) of Morocco in 2007 to that in 2013?
Provide a short and direct response. 0.45. What is the ratio of the Exports(as % of merchandise exports) of Yemen, Rep. in 2007 to that in 2013?
Your response must be concise. 1.2. What is the ratio of the Exports(as % of merchandise exports) of Arab World in 2008 to that in 2010?
Your response must be concise. 0.96. What is the ratio of the Exports(as % of merchandise exports) in Mauritania in 2008 to that in 2010?
Your answer should be very brief. 1.31e+04. What is the ratio of the Exports(as % of merchandise exports) in Morocco in 2008 to that in 2010?
Your answer should be compact. 2.01. What is the ratio of the Exports(as % of merchandise exports) of Yemen, Rep. in 2008 to that in 2010?
Your response must be concise. 1.01. What is the ratio of the Exports(as % of merchandise exports) in Arab World in 2008 to that in 2013?
Ensure brevity in your answer.  0.95. What is the ratio of the Exports(as % of merchandise exports) of Mauritania in 2008 to that in 2013?
Make the answer very short. 7.3. What is the ratio of the Exports(as % of merchandise exports) of Morocco in 2008 to that in 2013?
Offer a very short reply. 0.43. What is the ratio of the Exports(as % of merchandise exports) of Yemen, Rep. in 2008 to that in 2013?
Ensure brevity in your answer.  1.22. What is the ratio of the Exports(as % of merchandise exports) in Arab World in 2010 to that in 2013?
Give a very brief answer. 0.99. What is the ratio of the Exports(as % of merchandise exports) in Mauritania in 2010 to that in 2013?
Offer a terse response. 0. What is the ratio of the Exports(as % of merchandise exports) of Morocco in 2010 to that in 2013?
Offer a terse response. 0.21. What is the ratio of the Exports(as % of merchandise exports) in Yemen, Rep. in 2010 to that in 2013?
Ensure brevity in your answer.  1.2. What is the difference between the highest and the second highest Exports(as % of merchandise exports) of Arab World?
Offer a terse response. 0.66. What is the difference between the highest and the second highest Exports(as % of merchandise exports) in Mauritania?
Offer a terse response. 4.07. What is the difference between the highest and the second highest Exports(as % of merchandise exports) in Morocco?
Make the answer very short. 2.76. What is the difference between the highest and the second highest Exports(as % of merchandise exports) of Yemen, Rep.?
Offer a terse response. 1.41. What is the difference between the highest and the lowest Exports(as % of merchandise exports) of Arab World?
Make the answer very short. 4.03. What is the difference between the highest and the lowest Exports(as % of merchandise exports) of Mauritania?
Your answer should be very brief. 25.74. What is the difference between the highest and the lowest Exports(as % of merchandise exports) in Morocco?
Offer a very short reply. 3.96. What is the difference between the highest and the lowest Exports(as % of merchandise exports) in Yemen, Rep.?
Keep it short and to the point. 20.77. 